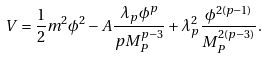<formula> <loc_0><loc_0><loc_500><loc_500>V = \frac { 1 } { 2 } m ^ { 2 } \phi ^ { 2 } - A \frac { \lambda _ { p } \phi ^ { p } } { p M ^ { p - 3 } _ { P } } + \lambda ^ { 2 } _ { p } \frac { \phi ^ { 2 ( p - 1 ) } } { M _ { P } ^ { 2 ( p - 3 ) } } .</formula> 